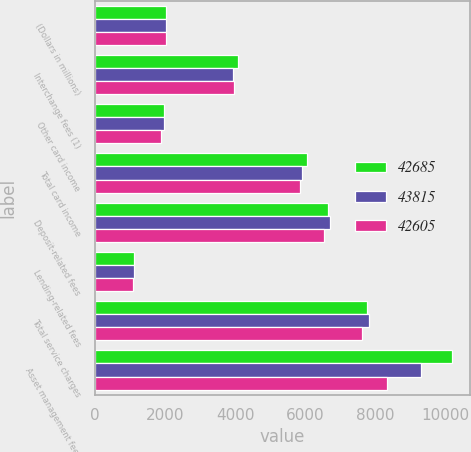Convert chart to OTSL. <chart><loc_0><loc_0><loc_500><loc_500><stacked_bar_chart><ecel><fcel>(Dollars in millions)<fcel>Interchange fees (1)<fcel>Other card income<fcel>Total card income<fcel>Deposit-related fees<fcel>Lending-related fees<fcel>Total service charges<fcel>Asset management fees<nl><fcel>42685<fcel>2018<fcel>4093<fcel>1958<fcel>6051<fcel>6667<fcel>1100<fcel>7767<fcel>10189<nl><fcel>43815<fcel>2017<fcel>3942<fcel>1960<fcel>5902<fcel>6708<fcel>1110<fcel>7818<fcel>9310<nl><fcel>42605<fcel>2016<fcel>3960<fcel>1891<fcel>5851<fcel>6545<fcel>1093<fcel>7638<fcel>8328<nl></chart> 